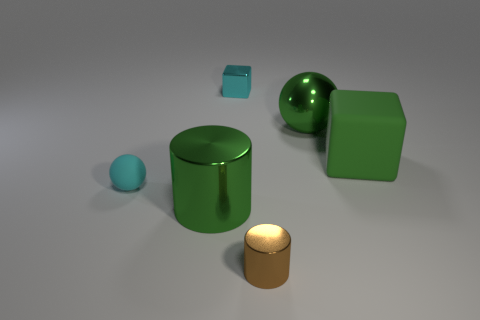What number of other metal things are the same shape as the tiny brown metallic thing?
Your response must be concise. 1. What is the size of the brown thing that is the same material as the big sphere?
Your answer should be compact. Small. What number of green matte cubes have the same size as the brown metallic thing?
Keep it short and to the point. 0. What size is the cube that is the same color as the shiny sphere?
Offer a terse response. Large. What is the color of the cylinder that is to the right of the green metal object that is in front of the large green metallic ball?
Provide a short and direct response. Brown. Is there a tiny ball that has the same color as the tiny rubber object?
Your answer should be compact. No. What is the color of the ball that is the same size as the cyan metal cube?
Give a very brief answer. Cyan. Is the small ball left of the large cylinder made of the same material as the tiny cyan cube?
Offer a very short reply. No. Is there a metal cylinder that is on the left side of the small cyan thing on the right side of the big shiny object that is in front of the rubber cube?
Provide a succinct answer. Yes. Do the large object in front of the big matte cube and the green matte object have the same shape?
Your response must be concise. No. 